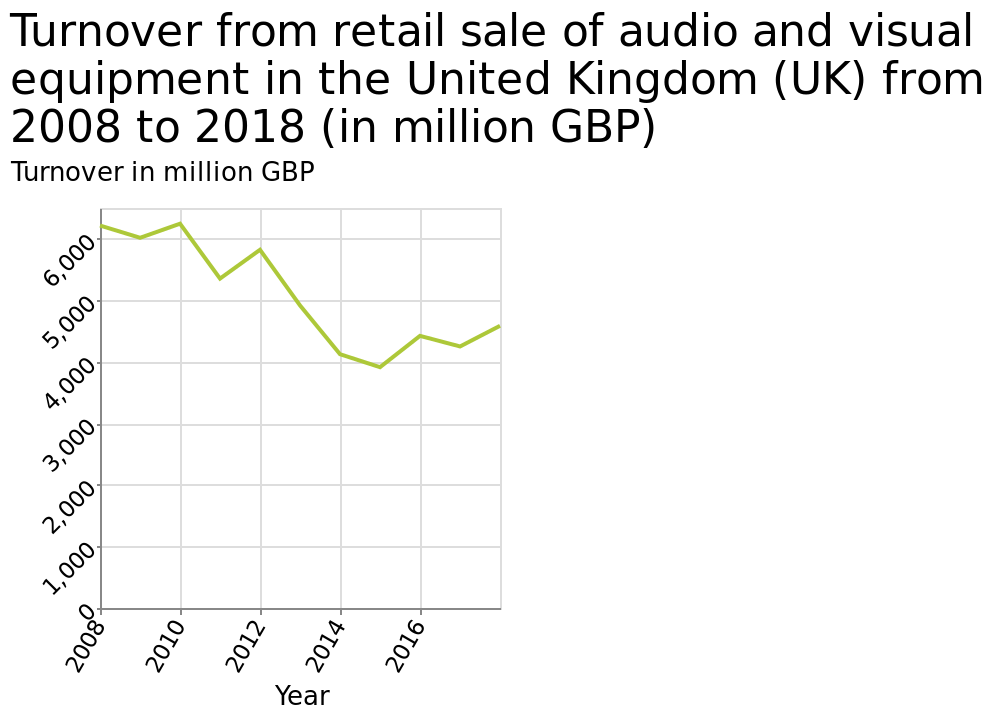<image>
What type of scale is used for the y-axis? A linear scale is used for the y-axis. What is the minimum value on the x-axis? The minimum value on the x-axis is 2008. 